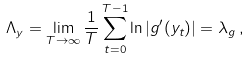Convert formula to latex. <formula><loc_0><loc_0><loc_500><loc_500>\Lambda _ { y } = \lim _ { T \rightarrow \infty } \frac { 1 } { T } \sum ^ { T - 1 } _ { t = 0 } \ln | g ^ { \prime } ( y _ { t } ) | = \lambda _ { g } \, ,</formula> 